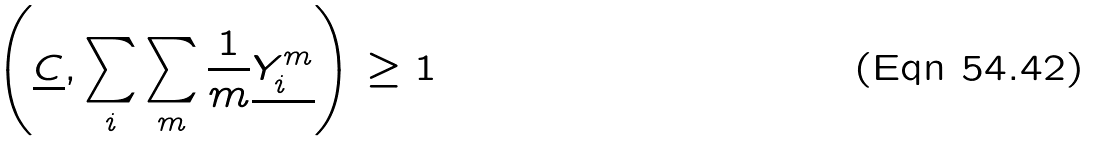Convert formula to latex. <formula><loc_0><loc_0><loc_500><loc_500>\left ( \underline { C } , \sum _ { i } \sum _ { m } \frac { 1 } { m } \underline { Y _ { i } ^ { m } } \right ) \geq 1</formula> 